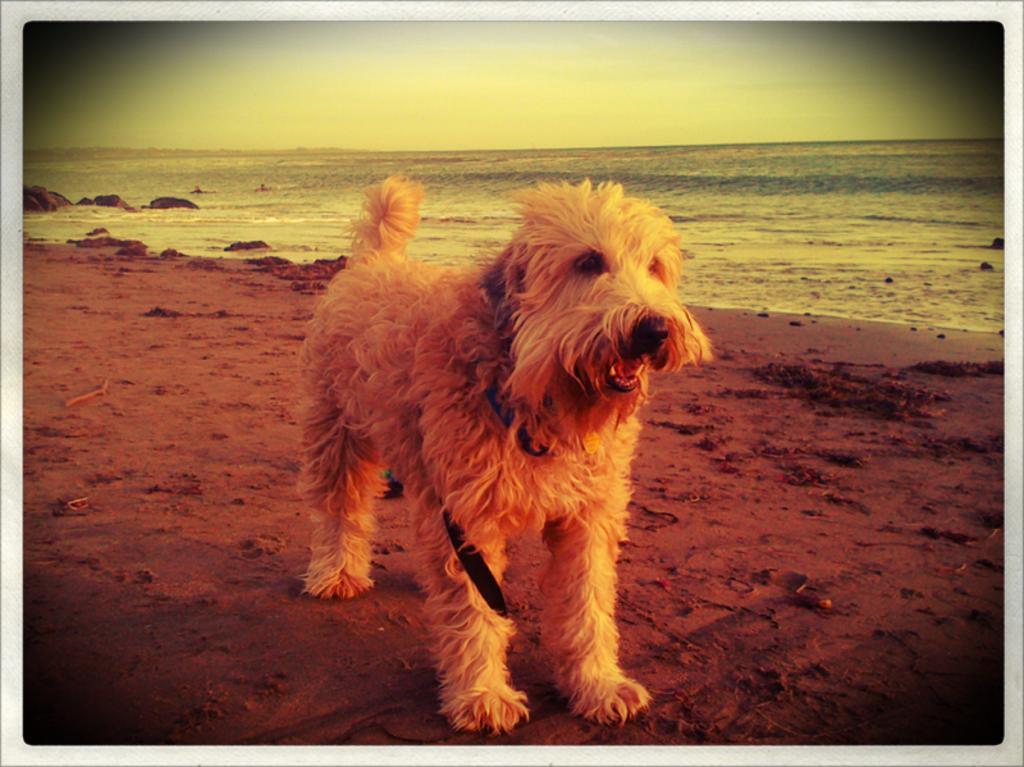Please provide a concise description of this image. In this picture there is a dog in the center of the image on a muddy floor and there is water in the background area of the image. 